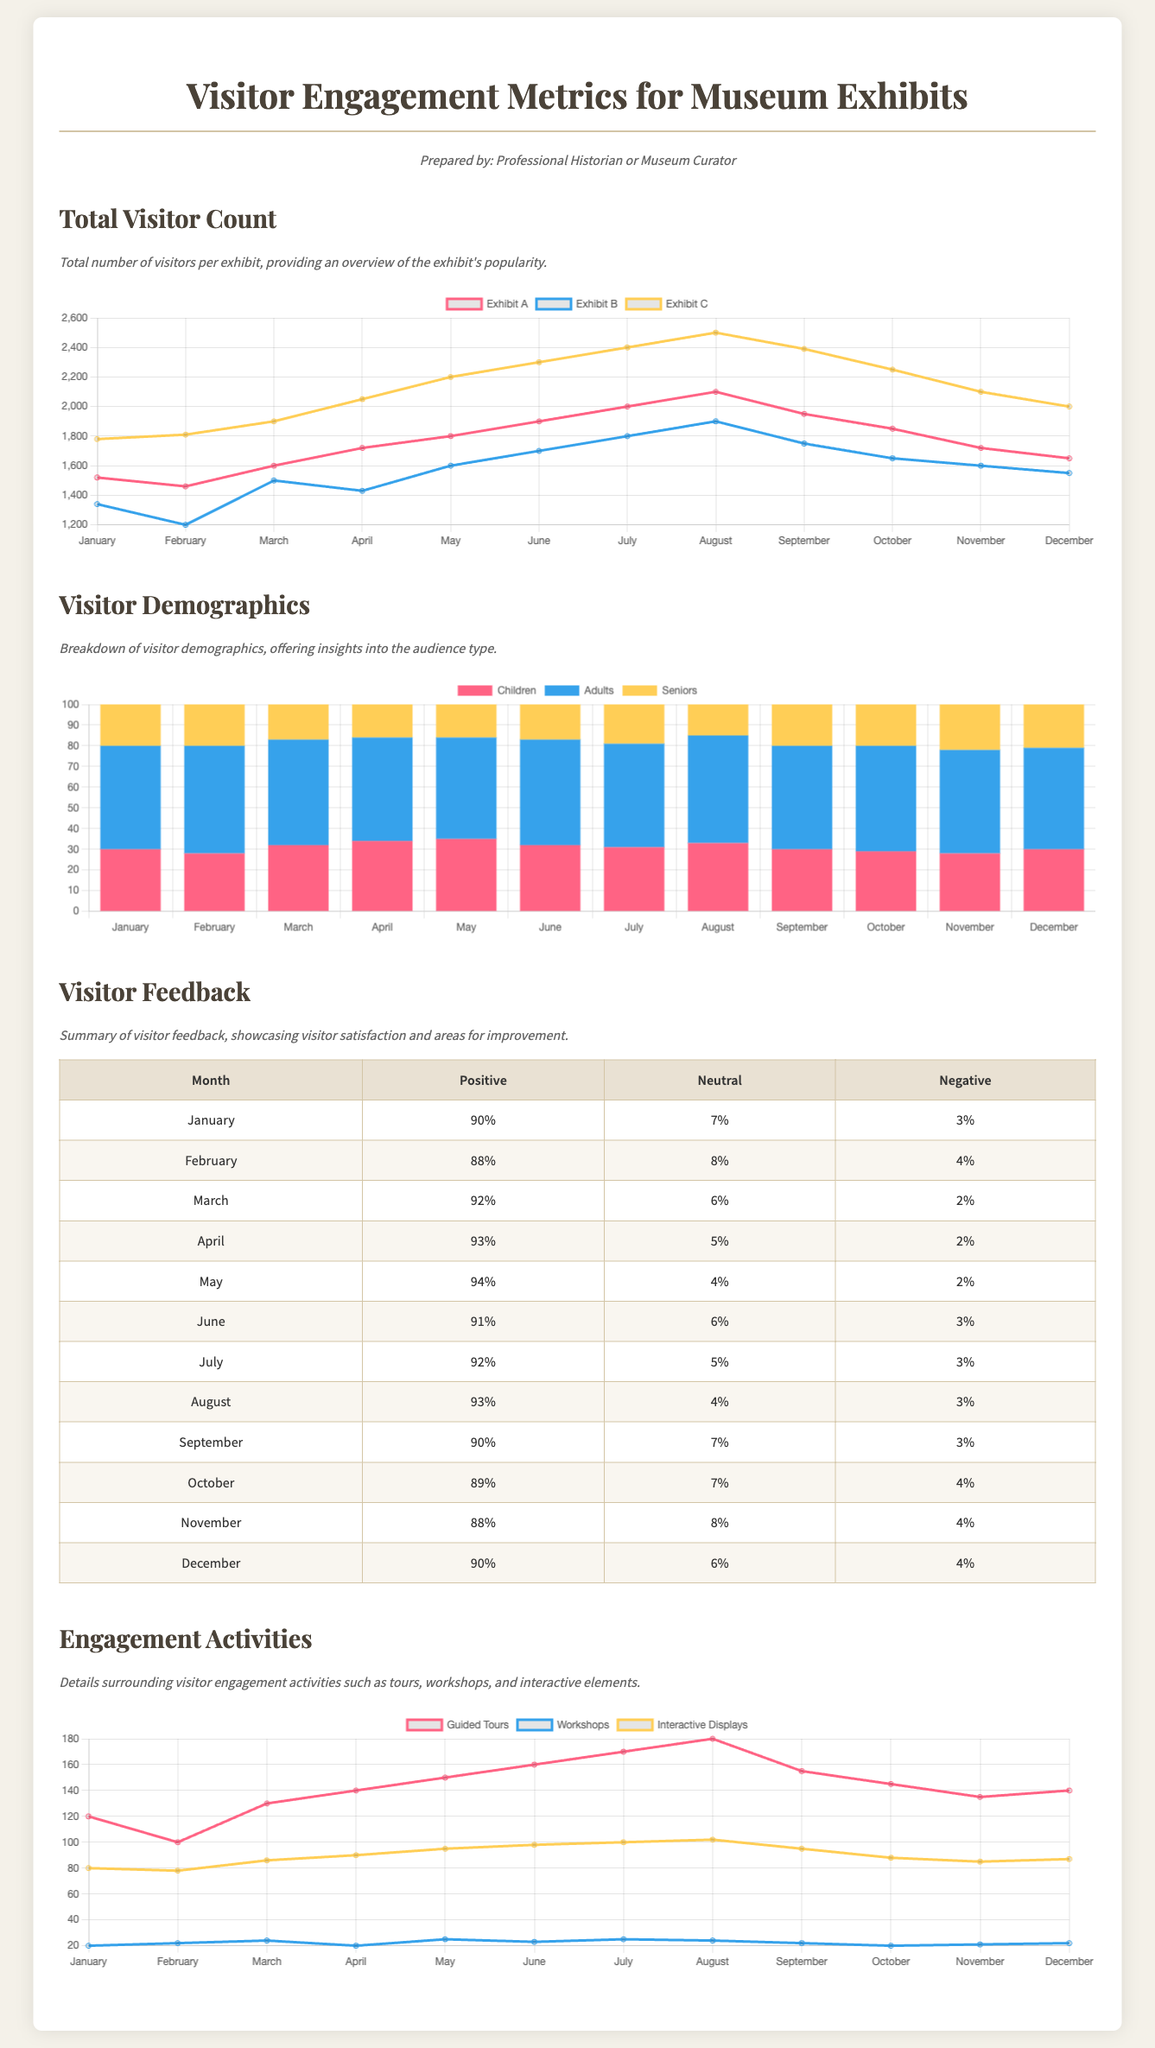What is the highest visitor count for Exhibit C? The highest visitor count for Exhibit C can be found by examining the data for each month in the visitor count chart. The maximum value is 2500.
Answer: 2500 In which month did Exhibit A have the least visitors? The least visitors for Exhibit A can be identified by checking the monthly visitor counts. The minimum value is in January with 1520.
Answer: January What percentage of positive feedback was received in May? The percentage of positive feedback for May is stated in the feedback table. It is 94%.
Answer: 94% How many seniors visited in March? The number of seniors in March can be found in the demographics chart. The value is 17.
Answer: 17 What was the total number of Guided Tours provided in July? The total number of Guided Tours in July can be seen in the engagement activities chart. The number is 170.
Answer: 170 What demographic had the highest percentage in June? The demographic with the highest percentage in June can be determined from the demographics data. Adults had the highest at 51%.
Answer: Adults What is the average positive feedback percentage for the last quarter? The average positive feedback for the last quarter can be calculated using feedback percentages for October, November, and December, which are 89%, 88%, and 90%. The average is rounded to 89%.
Answer: 89% Which engagement activity had the highest participation in April? The highest participation in April can be identified from the activities chart; Guided Tours had 140 participants.
Answer: Guided Tours What is the overall trend indicated by the visitor count for Exhibit B? Observing the data for Exhibit B, the visitor count generally follows a declining trend, especially after July.
Answer: Declining trend 